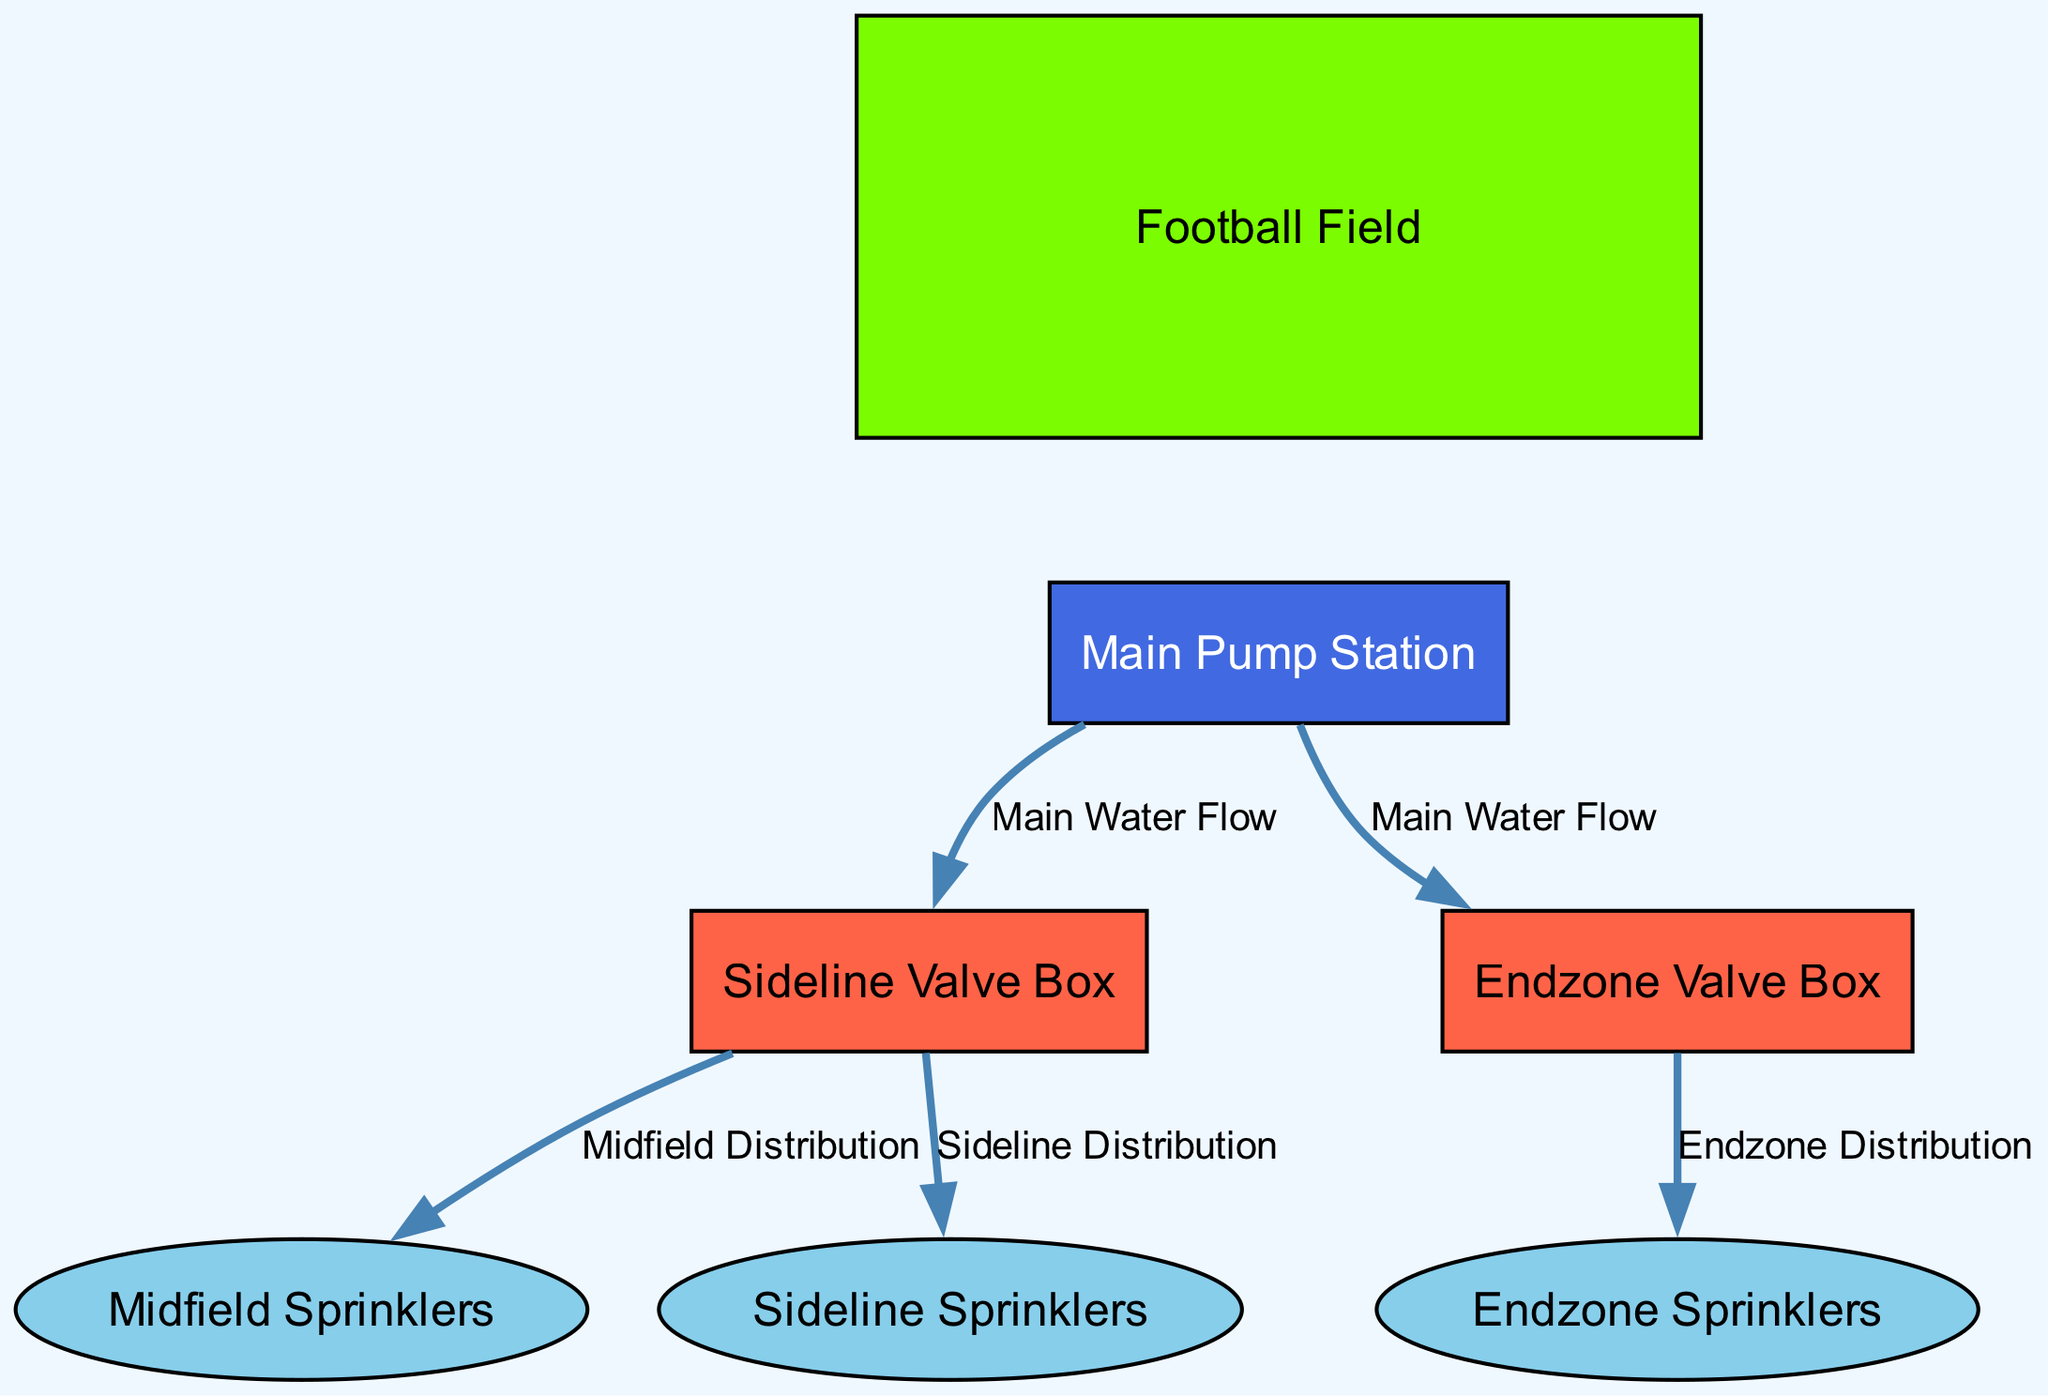What is the total number of nodes in the diagram? The diagram contains a total of six nodes: the football field, main pump station, two valve boxes, and three sprinklers. By counting each of these, we confirm that there are 6 nodes.
Answer: 6 What is the label of the node connected to the main pump station with sideline distribution? The main pump station connects to two nodes: one is the sideline valve box, and the edge leading to it is labeled "Sideline Distribution". Therefore, the label of the connected node is "Sideline Sprinklers".
Answer: Sideline Sprinklers Which node receives water flow from the endzone valve box? The endzone valve box connects to the endzone sprinklers, indicated by the edge labeled "Endzone Distribution". Therefore, this is the node that receives water flow from the endzone valve box.
Answer: Endzone Sprinklers How many valves are in the irrigation system? The diagram shows two valve boxes: one for the sideline and one for the endzone. Thus, there are a total of 2 valves in the irrigation system.
Answer: 2 Which node is indicated as the starting point for the main water flow? The main water flow starts from the main pump station, as indicated by the edges connecting it to both valve boxes. Thus, the main water flow originates from the "Main Pump Station".
Answer: Main Pump Station What is the color of the nodes representing the valves? The valve nodes are colored as "Tomato", which corresponds to the hex code #FF6347 used in the diagram for their representation.
Answer: Tomato How are the midfield sprinklers connected in the irrigation system? The midfield sprinklers are connected via the sideline valve box, as indicated by the edge labeled "Midfield Distribution" leading from the sideline valve box to the midfield sprinklers.
Answer: Sideline Valve Box Which node has the label "Endzone Valve Box"? The node with the label “Endzone Valve Box” is explicitly named as such and corresponds to the endzone valve box, which is one of the key components in the watering system.
Answer: Endzone Valve Box What is the color assigned to the football field node? The football field node is colored "Lawn Green", which matches the typical representation of grass in diagrams.
Answer: Lawn Green 